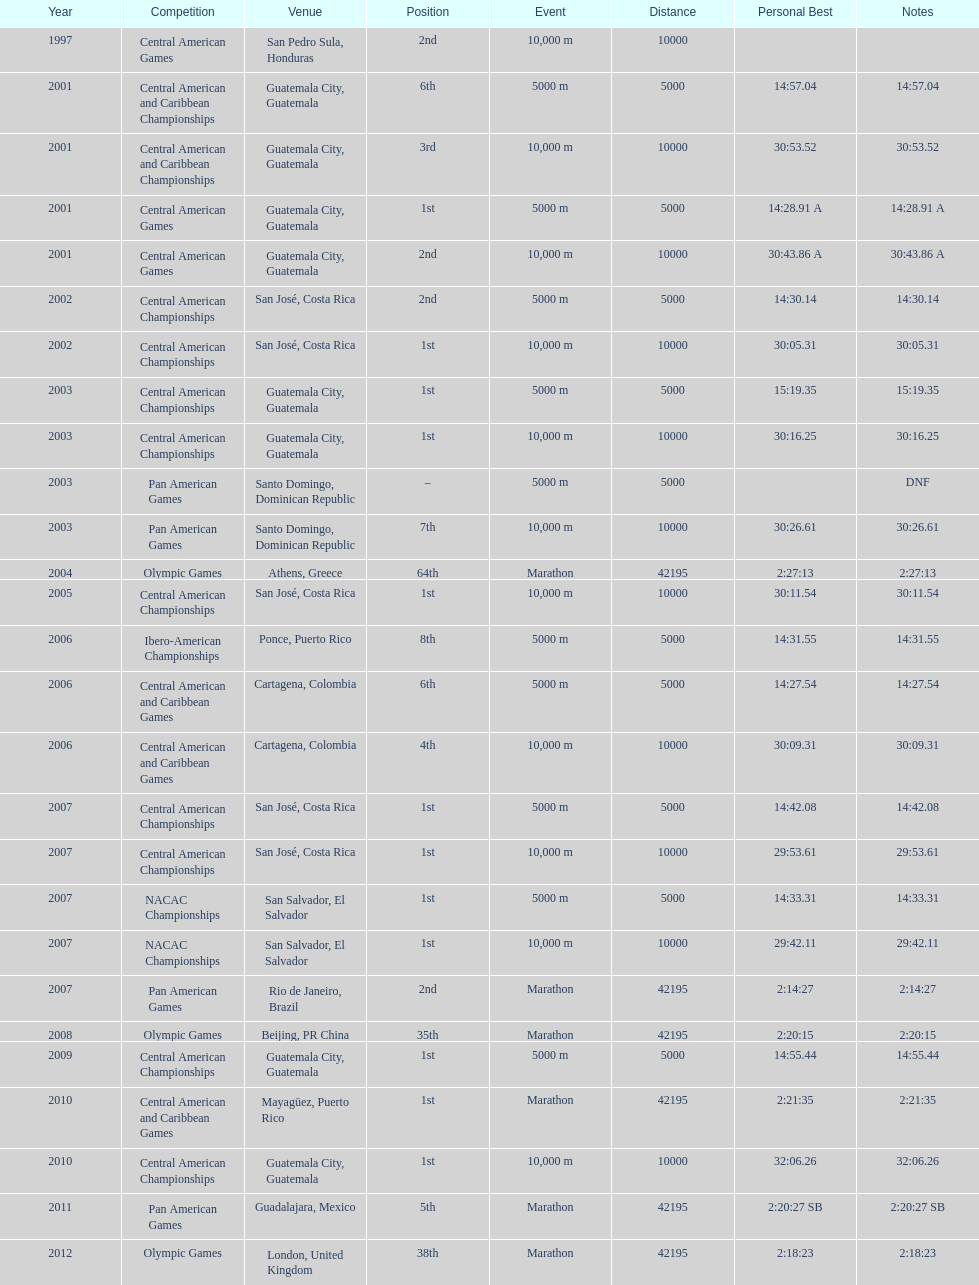Which game occupied the 2nd spot in the 2007 rankings? Pan American Games. 